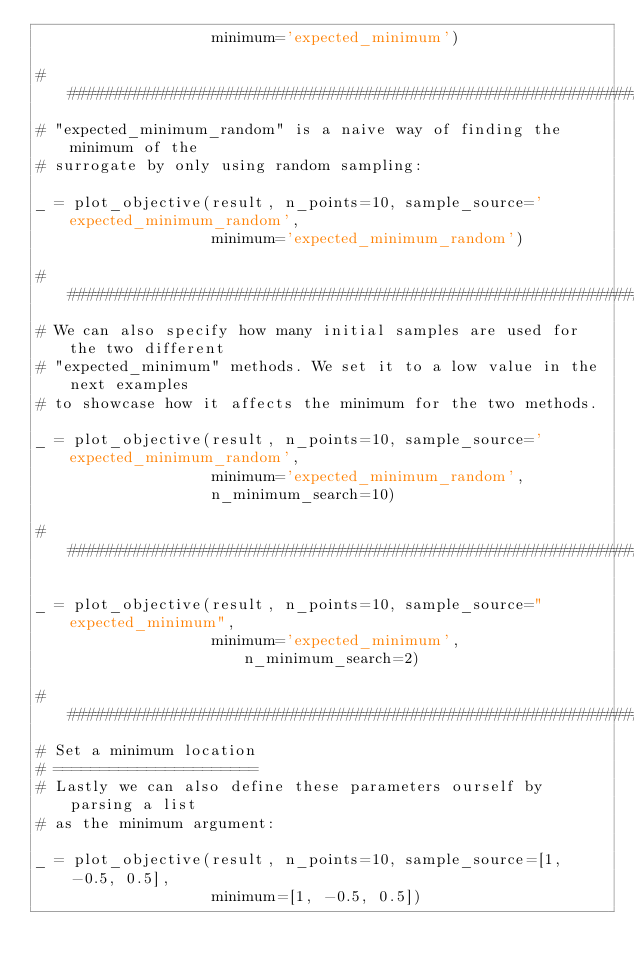Convert code to text. <code><loc_0><loc_0><loc_500><loc_500><_Python_>                   minimum='expected_minimum')

#############################################################################
# "expected_minimum_random" is a naive way of finding the minimum of the
# surrogate by only using random sampling:

_ = plot_objective(result, n_points=10, sample_source='expected_minimum_random',
                   minimum='expected_minimum_random')

#############################################################################
# We can also specify how many initial samples are used for the two different
# "expected_minimum" methods. We set it to a low value in the next examples
# to showcase how it affects the minimum for the two methods.

_ = plot_objective(result, n_points=10, sample_source='expected_minimum_random',
                   minimum='expected_minimum_random',
                   n_minimum_search=10)

#############################################################################

_ = plot_objective(result, n_points=10, sample_source="expected_minimum",
                   minimum='expected_minimum', n_minimum_search=2)

#############################################################################
# Set a minimum location
# ======================
# Lastly we can also define these parameters ourself by parsing a list
# as the minimum argument:

_ = plot_objective(result, n_points=10, sample_source=[1, -0.5, 0.5],
                   minimum=[1, -0.5, 0.5])


</code> 